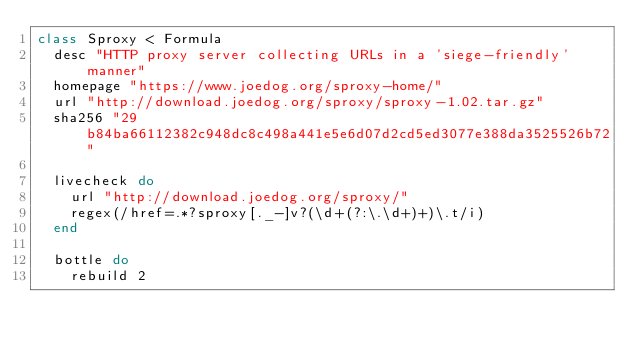<code> <loc_0><loc_0><loc_500><loc_500><_Ruby_>class Sproxy < Formula
  desc "HTTP proxy server collecting URLs in a 'siege-friendly' manner"
  homepage "https://www.joedog.org/sproxy-home/"
  url "http://download.joedog.org/sproxy/sproxy-1.02.tar.gz"
  sha256 "29b84ba66112382c948dc8c498a441e5e6d07d2cd5ed3077e388da3525526b72"

  livecheck do
    url "http://download.joedog.org/sproxy/"
    regex(/href=.*?sproxy[._-]v?(\d+(?:\.\d+)+)\.t/i)
  end

  bottle do
    rebuild 2</code> 